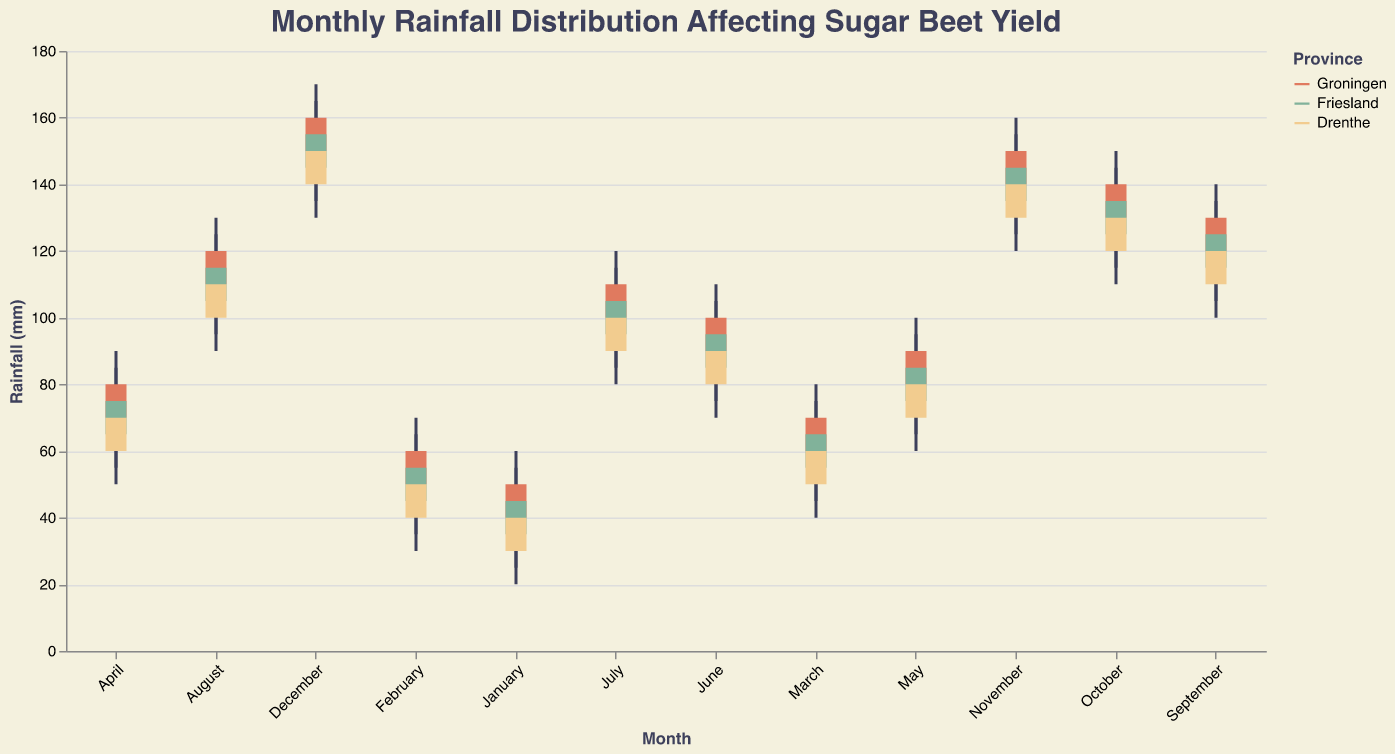What is the title of the plot? The title is located at the top of the plot and clearly mentions the purpose of the plot.
Answer: Monthly Rainfall Distribution Affecting Sugar Beet Yield What is the highest rainfall in Groningen and in which month does it occur? To find the highest rainfall, look at the "High" values for Groningen. The highest value is 170 mm, which occurs in December.
Answer: December Which location has the lowest recorded rainfall, and what is that value? The location with the lowest recorded rainfall would be where the "Low" value is the smallest. The lowest value is 20 mm in Drenthe in January.
Answer: Drenthe, 20 mm How does the median rainfall in Friesland compare between January and June? Calculate the median (Open + Close) / 2 for both months. For January, (35 + 45) / 2 = 40. For June, (85 + 95) / 2 = 90. Compare these values.
Answer: January: 40 mm, June: 90 mm. June is higher Between which months is there the biggest increase in "Open" rainfall values for Drenthe? Look for the largest difference in the "Open" values for consecutive months. The biggest increase is from May to June, where the "Open" value increases from 70 mm to 80 mm (+10 mm).
Answer: May to June What are the color representations of the provinces? The legend in the plot identifies the color mapped to each province. Groningen is represented by a reddish color, Friesland by a greenish color, and Drenthe by a yellowish color.
Answer: Groningen: reddish, Friesland: greenish, Drenthe: yellowish In which month does Groningen experience the maximum difference between high and low rainfall values? Calculate the difference (High - Low) for each month in Groningen. The maximum difference is 30 mm, which occurs in December.
Answer: December Across all three locations, in which month does the rainfall range (difference between high and low) appear to be the smallest? Compare the differences (High - Low) for each month across all locations. The smallest range appears in January in Friesland for 30 mm - 25 mm = 5 mm.
Answer: January in Friesland What is the trend of the "Close" rainfall value in Groningen from January to December? Observe the "Close" values for Groningen across all months. The trend is increasing as it goes from 50 mm in January to 160 mm in December.
Answer: Increasing Which location shows a consistent increase in "Open" values month over month without any decreases? Review the "Open" values month over month for each location. Groningen has consistent increases in "Open" values without any month showing a decrease.
Answer: Groningen 